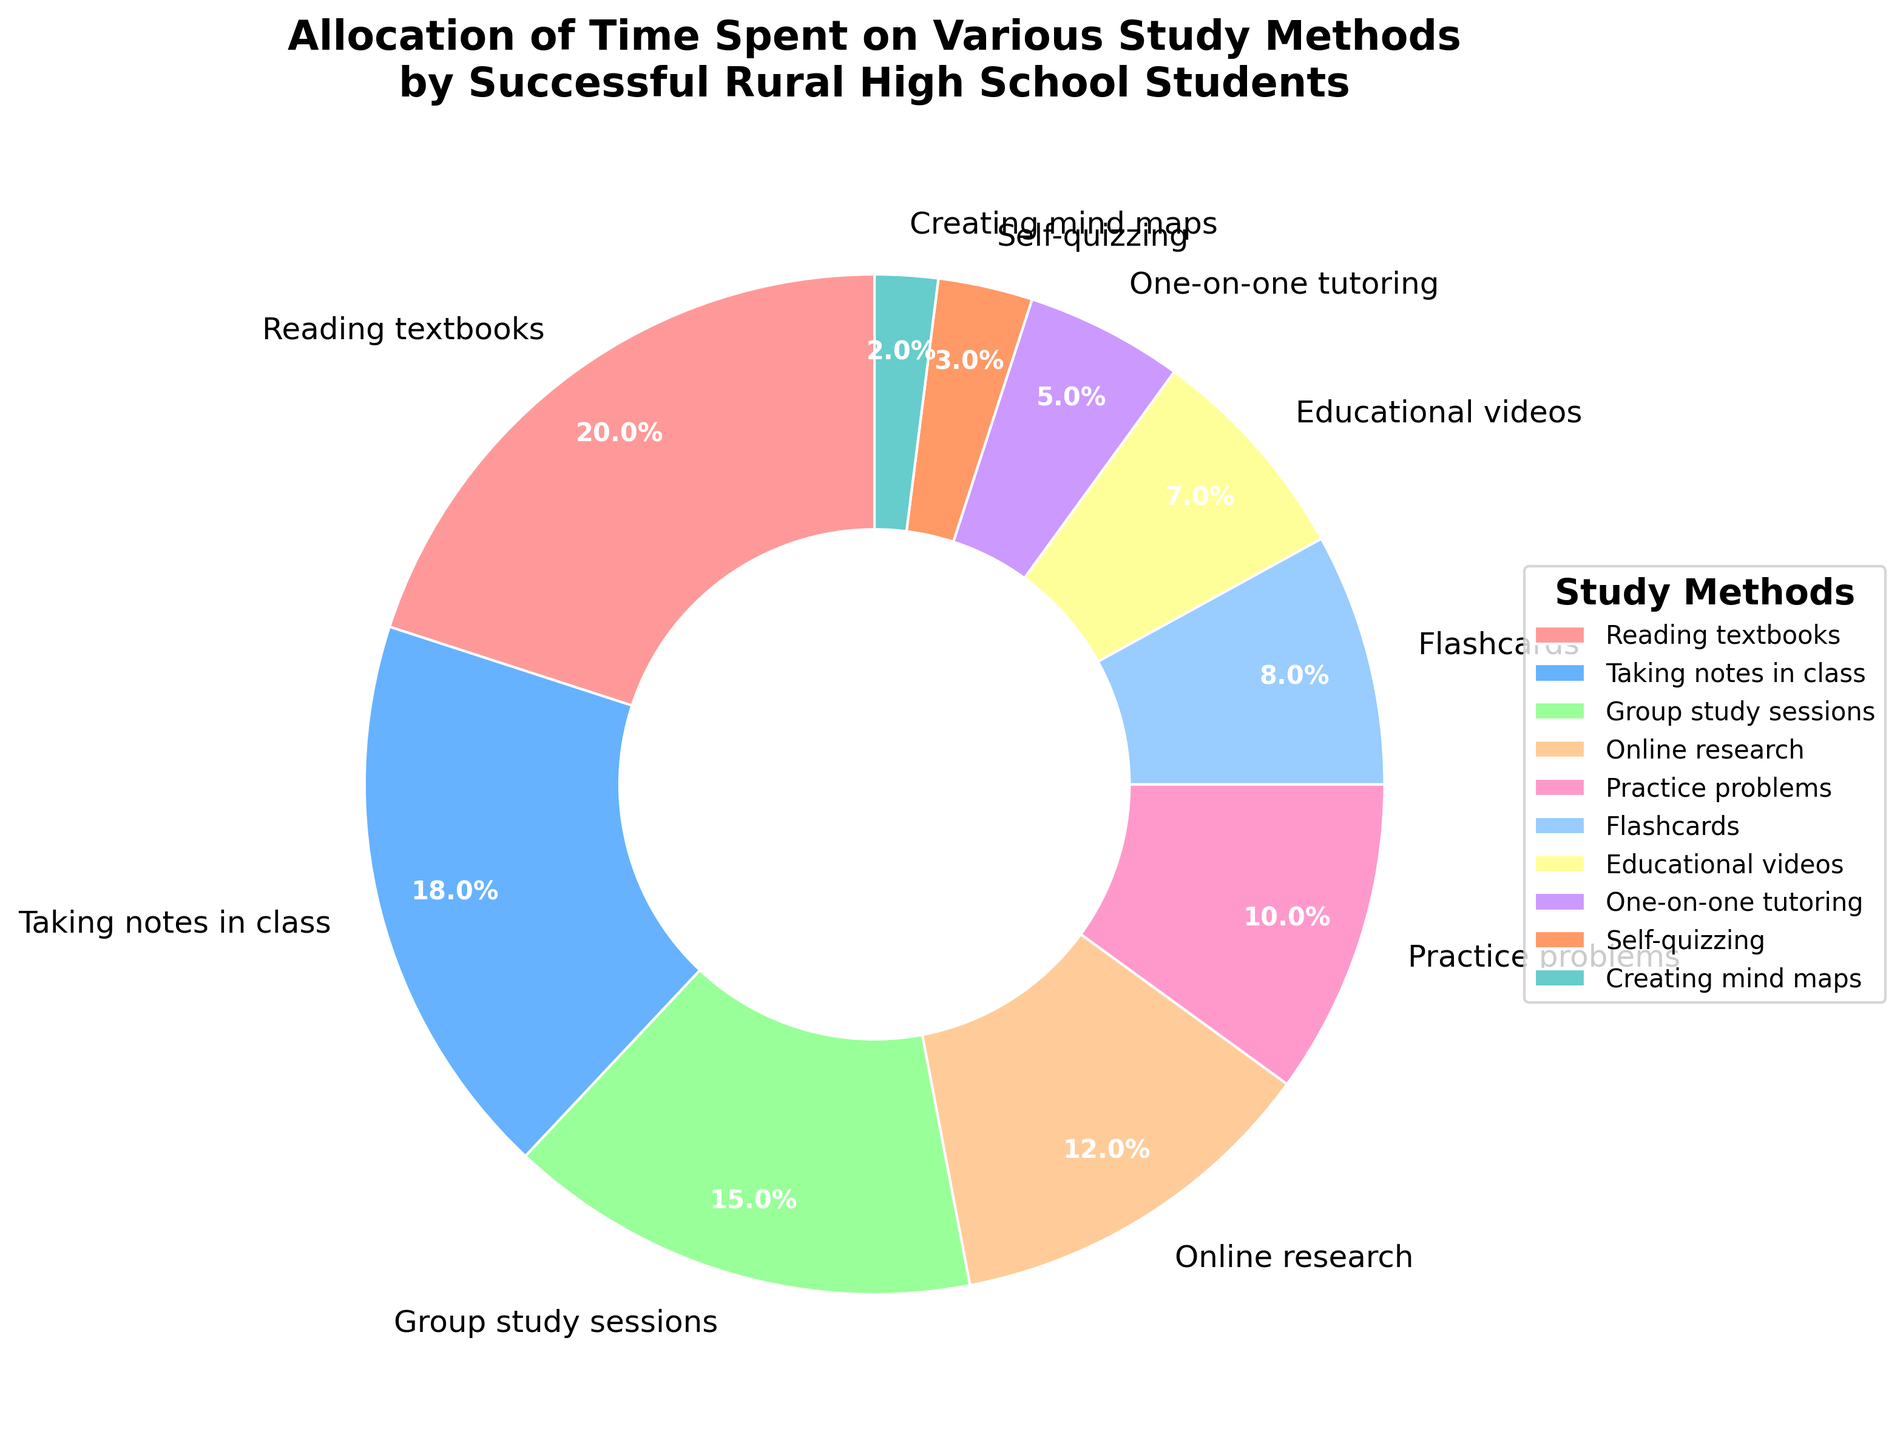What are the top three study methods with the highest percentage allocation? Look at the pie chart and identify the three largest slices. The study methods with the highest percentages are Reading textbooks (20%), Taking notes in class (18%), and Group study sessions (15%).
Answer: Reading textbooks, Taking notes in class, Group study sessions Which study method takes up more time: Online research or Flashcards? Compare the percentages of Online research (12%) and Flashcards (8%) as shown on the pie chart. Since 12% is greater than 8%, Online research takes up more time.
Answer: Online research How much more time is spent on Practice problems compared to Self-quizzing? Find the percentage of time spent on Practice problems (10%) and Self-quizzing (3%), then subtract the smaller percentage from the larger one. The difference is 10% - 3% = 7%.
Answer: 7% Which study methods together constitute exactly 22% of the total time allocation? Identify the study methods with percentages that sum up to 22%. The available percentages are Creating mind maps (2%) and Self-quizzing (3%), which sum to 5%, or there are no possible exact combinations that add up to 22% based on the values provided.
Answer: None What color represents the Reading textbooks method? Locate the slice for Reading textbooks on the pie chart and observe its color, which is the color specified for the first slice. The color for Reading textbooks in the generated chart is likely a shade of red (e.g., pinkish red).
Answer: Red How much total time is allocated to Flashcards, Educational videos, and One-on-one tutoring? Add the percentages for Flashcards (8%), Educational videos (7%), and One-on-one tutoring (5%). The total time allocated is 8% + 7% + 5% = 20%.
Answer: 20% Is more time spent on taking notes in class than on group study sessions and online research combined? First, find the percentages for Taking notes in class (18%), Group study sessions (15%), and Online research (12%). Then sum the percentages for group study sessions and online research (15% + 12% = 27%). Since 27% > 18%, more time is spent combined on these than on taking notes.
Answer: No What is the difference in time allocation between the highest and lowest study methods? Determine the highest (Reading textbooks, 20%) and lowest (Creating mind maps, 2%) percentages and subtract the smallest from the largest. The difference is 20% - 2% = 18%.
Answer: 18% 